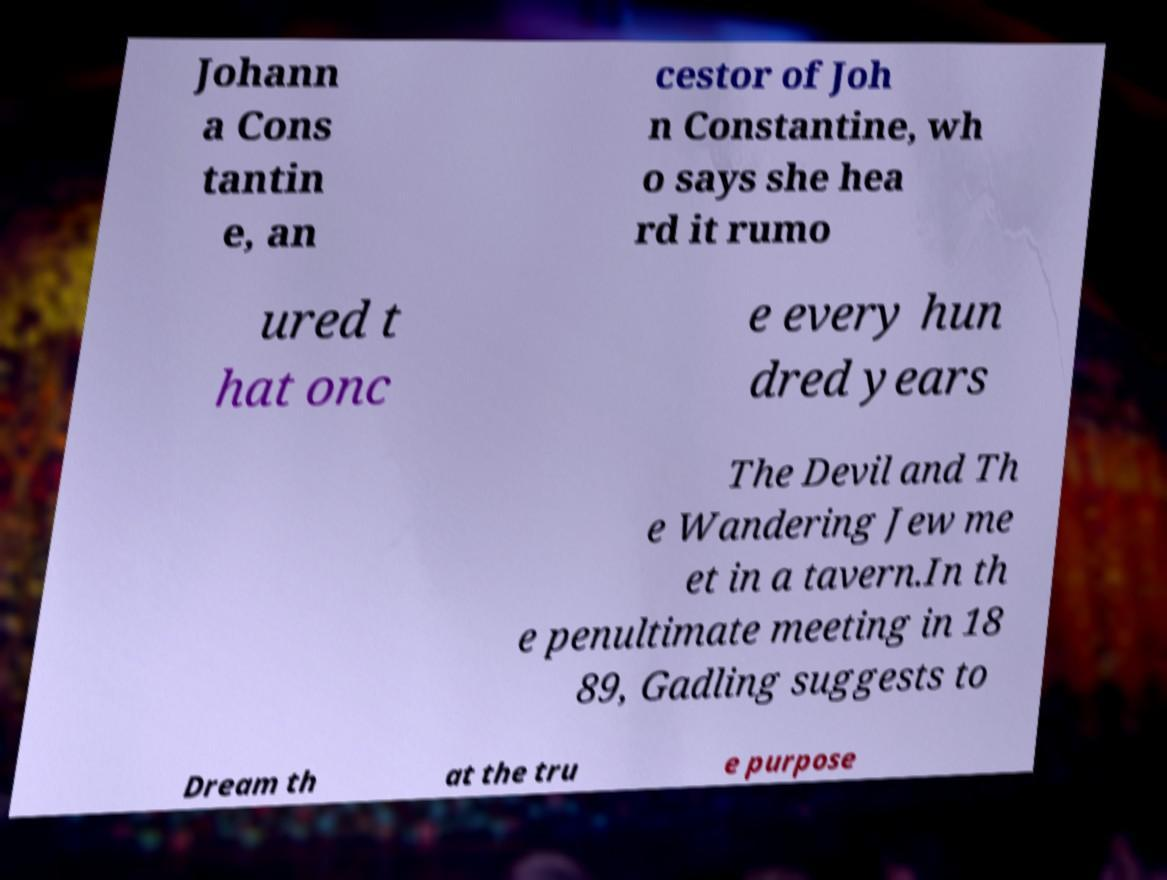Can you accurately transcribe the text from the provided image for me? Johann a Cons tantin e, an cestor of Joh n Constantine, wh o says she hea rd it rumo ured t hat onc e every hun dred years The Devil and Th e Wandering Jew me et in a tavern.In th e penultimate meeting in 18 89, Gadling suggests to Dream th at the tru e purpose 